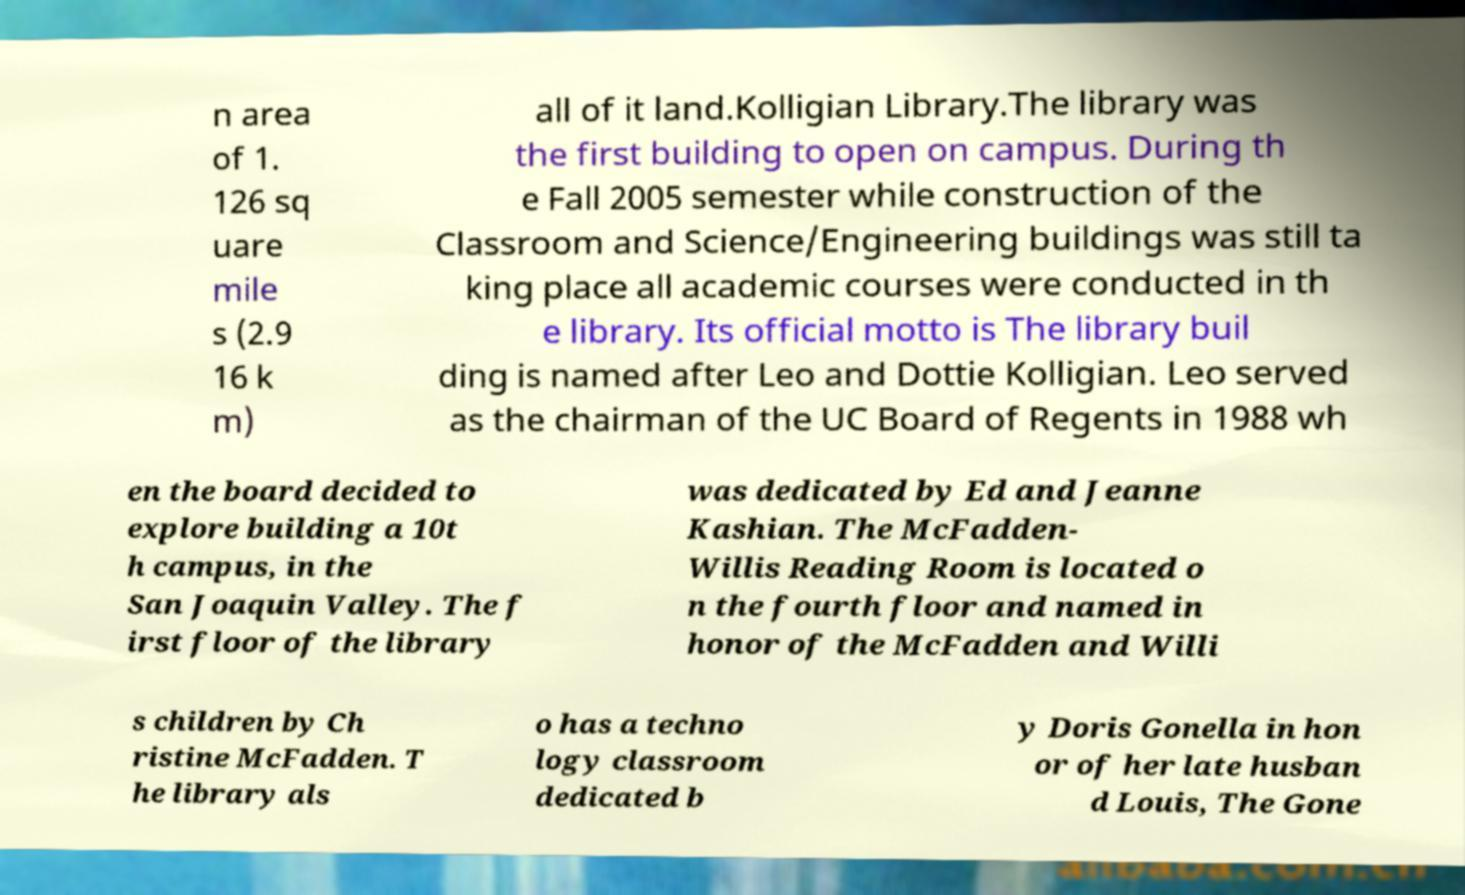Can you read and provide the text displayed in the image?This photo seems to have some interesting text. Can you extract and type it out for me? n area of 1. 126 sq uare mile s (2.9 16 k m) all of it land.Kolligian Library.The library was the first building to open on campus. During th e Fall 2005 semester while construction of the Classroom and Science/Engineering buildings was still ta king place all academic courses were conducted in th e library. Its official motto is The library buil ding is named after Leo and Dottie Kolligian. Leo served as the chairman of the UC Board of Regents in 1988 wh en the board decided to explore building a 10t h campus, in the San Joaquin Valley. The f irst floor of the library was dedicated by Ed and Jeanne Kashian. The McFadden- Willis Reading Room is located o n the fourth floor and named in honor of the McFadden and Willi s children by Ch ristine McFadden. T he library als o has a techno logy classroom dedicated b y Doris Gonella in hon or of her late husban d Louis, The Gone 